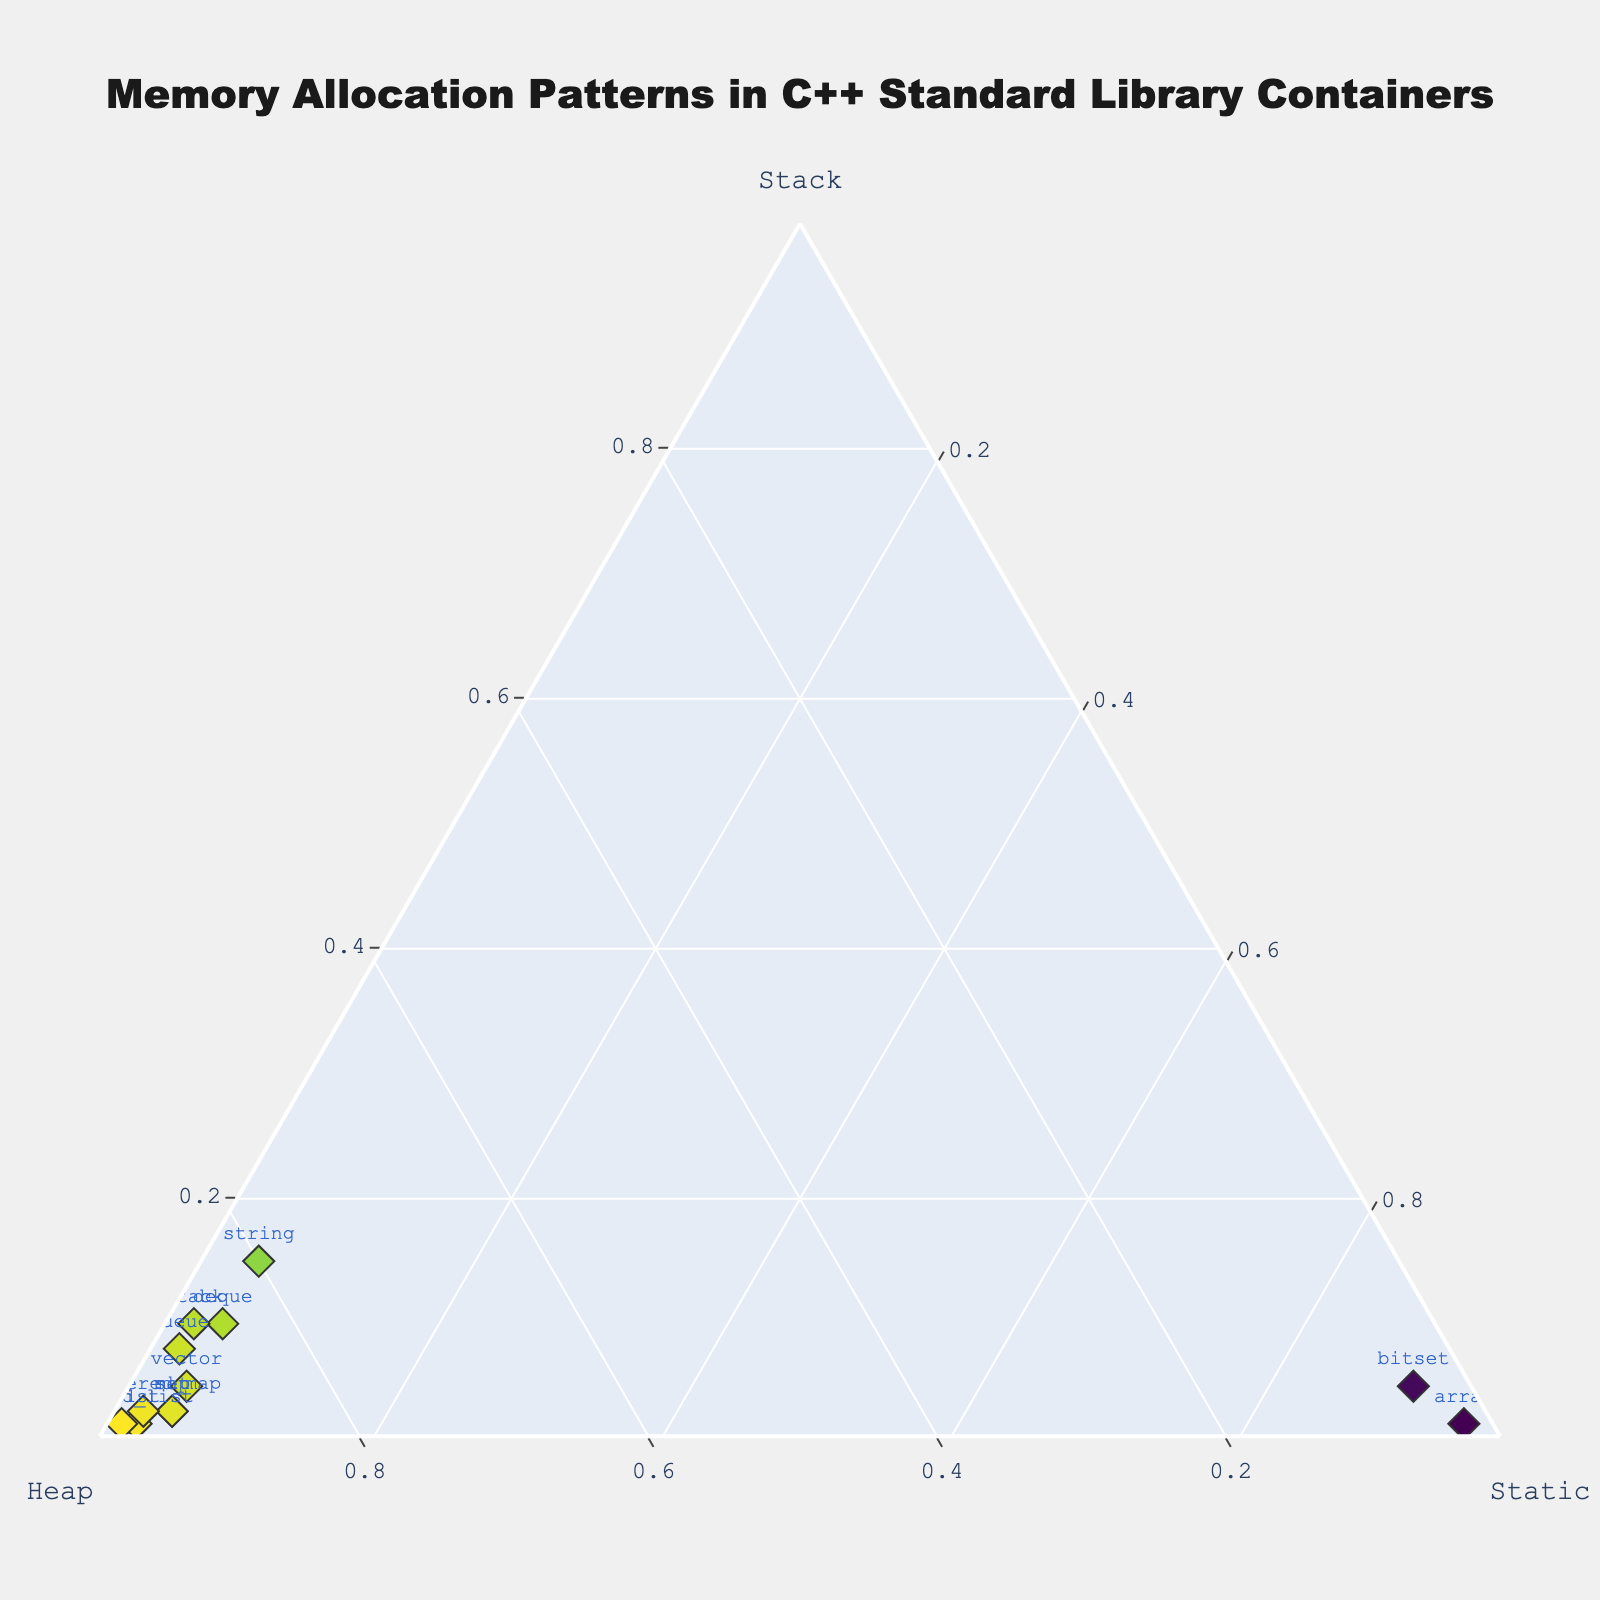What kind of memory allocation pattern does the plot show for the vector container? The figure shows the allocation patterns for different containers in a ternary plot. For the vector container, it primarily allocates memory on the heap (90%) with minimal use of stack (5%) and static (5%) memory.
Answer: Primarily heap (90%) Which container has the highest static memory allocation? The data points in the ternary plot show that the array container has the highest static memory allocation at 95%.
Answer: array How does the memory allocation of string compare to that of vector? According to the plot, the string container allocates more memory on the stack (15%) compared to the vector (5%). Both have the same static memory allocation (5%), and the vector allocates slightly more on the heap (90% vs. 80%).
Answer: String has more stack, less heap, same static Which container exhibits the least reliance on stack memory? The forward_list container has the smallest stack memory allocation at 2%.
Answer: forward_list What is the combined heap memory allocation for list and unordered_map? According to the plot, the list allocates 95% and the unordered_map allocates 94% of their memory on the heap. The combined heap allocation is 95% + 94% = 189%.
Answer: 189% Is there any container that allocates equally among stack, heap, and static? None of the containers in the plot have equal allocation among stack, heap, and static memory.
Answer: No Which container's allocation pattern is closest to uniform between stack and static? The bitset container allocates almost equally to stack (5%) and static (90%), but its heap allocation is also minimal (5%).
Answer: bitset What trend in memory allocation can be observed for containers that primarily use static memory? The containers with a high static memory allocation, like array and bitset, rely less on heap memory and minimally on stack memory.
Answer: High static, low heap, minimal stack Which container allocates the most to the heap and what percentage is it? The forward_list container allocates the most memory to the heap at 96%.
Answer: forward_list, 96% How does the memory allocation of queue compare to stack? Both queue and stack allocate similar proportions to the stack (10% and 10% respectively) and static memory (3% and 3%), but the queue allocates slightly more to the heap (89%) than the stack does (87%).
Answer: Similar stack and static, queue has more heap 